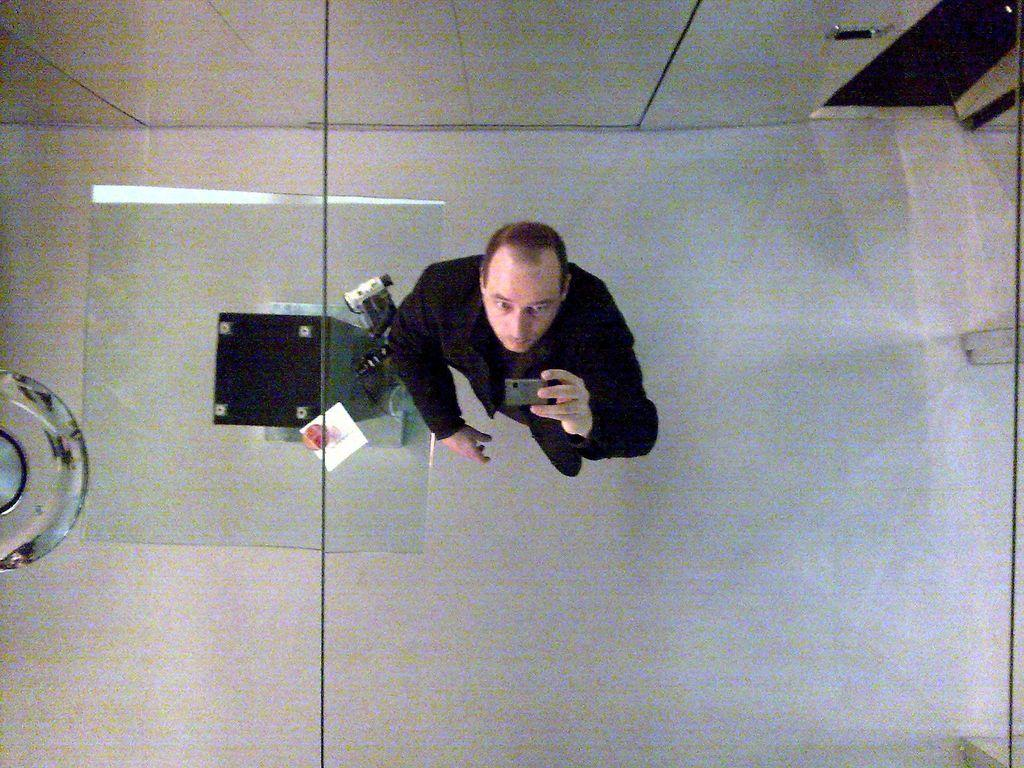Who or what is the main subject in the image? There is a person in the image. What is the person doing in the image? The person is taking a picture of a roof. Can you describe the setting or location in the image? There is a room on the right side behind the person. What type of bed can be seen in the image? There is no bed present in the image. How many toes are visible on the person's foot in the image? The image does not show the person's foot or toes. --- Facts: 1. There is a car in the image. 2. The car is parked on the street. 3. There are trees in the background. 4. The sky is visible in the background. Absurd Topics: fish, piano, volcano Conversation: What is the main subject in the image? There is a car in the image. Where is the car located in the image? The car is parked on the street. What can be seen in the background of the image? There are trees and the sky visible in the background. Reasoning: Let's think step by step in order to produce the conversation. We start by identifying the main subject in the image, which is the car. Then, we describe the location of the car, mentioning that it is parked on the street. Finally, we provide information about the background, noting the presence of trees and the sky. Absurd Question/Answer: Can you tell me how many fish are swimming in the car's engine in the image? There are no fish present in the image, and the car's engine is not visible. What type of piano can be seen in the background of the image? There is no piano present in the image; only trees and the sky are visible in the background. 